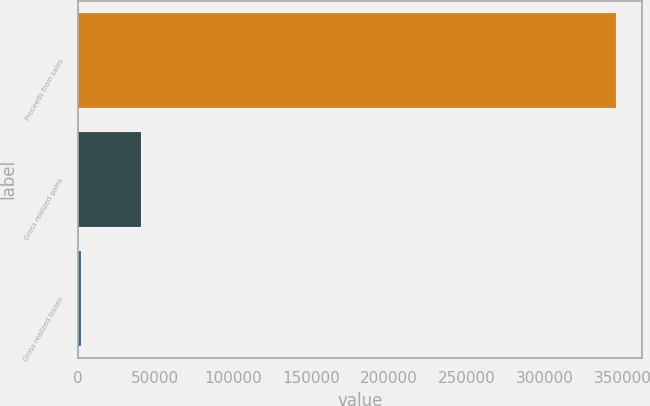Convert chart to OTSL. <chart><loc_0><loc_0><loc_500><loc_500><bar_chart><fcel>Proceeds from sales<fcel>Gross realized gains<fcel>Gross realized losses<nl><fcel>345601<fcel>40851<fcel>2477<nl></chart> 